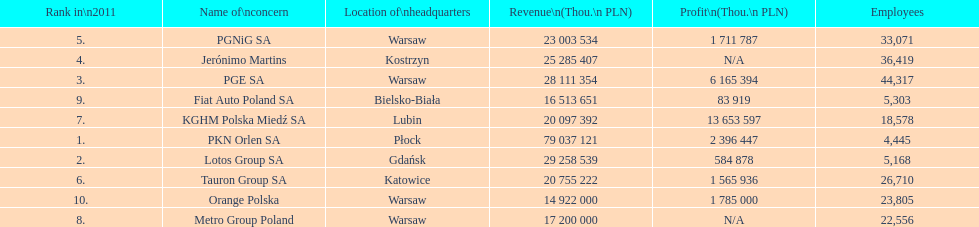What company is the only one with a revenue greater than 75,000,000 thou. pln? PKN Orlen SA. 